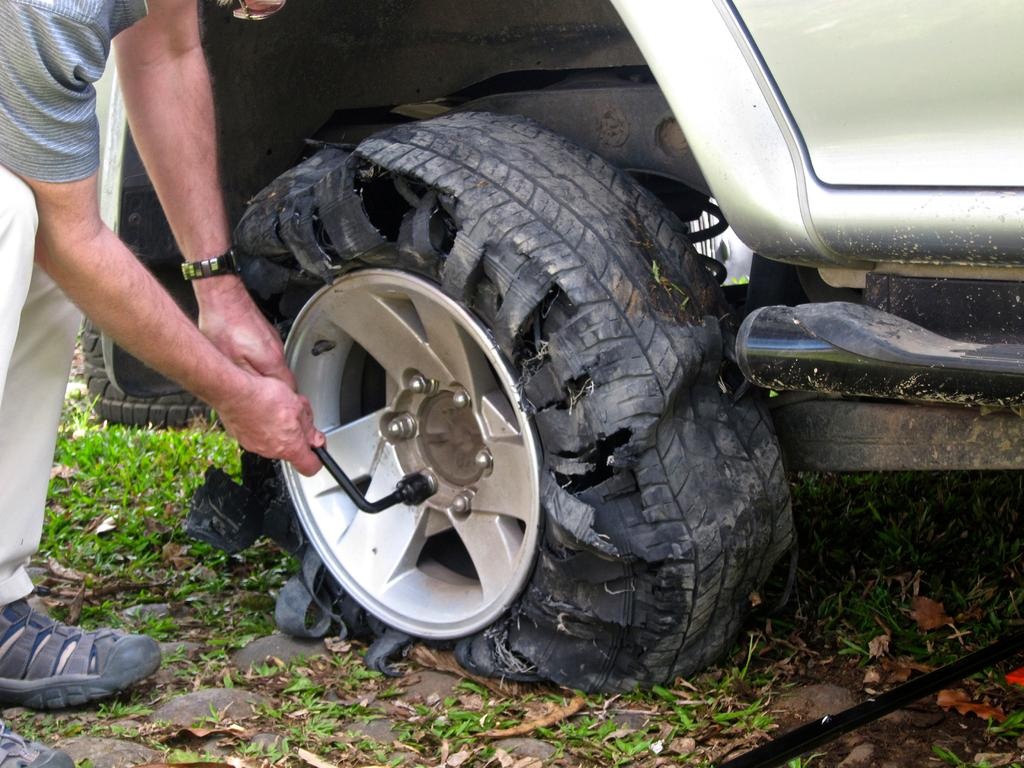What is the person holding in the image? The information provided does not specify what the person is holding. What type of vehicle can be seen in the image? There is a vehicle visible in the image, but the specific type is not mentioned. What type of vegetation is present in the image? Grass is present in the image. What additional natural elements can be seen in the image? Dry leaves are visible in the image. What color is the person's skirt in the image? There is no mention of a skirt in the image, so we cannot answer that question. 